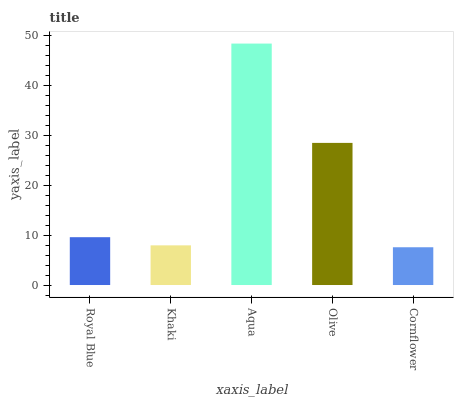Is Cornflower the minimum?
Answer yes or no. Yes. Is Aqua the maximum?
Answer yes or no. Yes. Is Khaki the minimum?
Answer yes or no. No. Is Khaki the maximum?
Answer yes or no. No. Is Royal Blue greater than Khaki?
Answer yes or no. Yes. Is Khaki less than Royal Blue?
Answer yes or no. Yes. Is Khaki greater than Royal Blue?
Answer yes or no. No. Is Royal Blue less than Khaki?
Answer yes or no. No. Is Royal Blue the high median?
Answer yes or no. Yes. Is Royal Blue the low median?
Answer yes or no. Yes. Is Aqua the high median?
Answer yes or no. No. Is Aqua the low median?
Answer yes or no. No. 